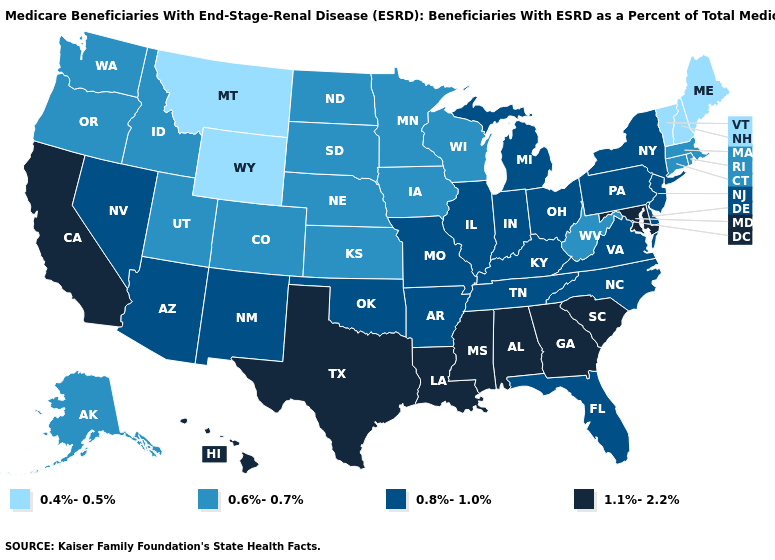What is the value of Mississippi?
Short answer required. 1.1%-2.2%. Name the states that have a value in the range 0.6%-0.7%?
Concise answer only. Alaska, Colorado, Connecticut, Idaho, Iowa, Kansas, Massachusetts, Minnesota, Nebraska, North Dakota, Oregon, Rhode Island, South Dakota, Utah, Washington, West Virginia, Wisconsin. Name the states that have a value in the range 0.4%-0.5%?
Be succinct. Maine, Montana, New Hampshire, Vermont, Wyoming. Name the states that have a value in the range 0.6%-0.7%?
Give a very brief answer. Alaska, Colorado, Connecticut, Idaho, Iowa, Kansas, Massachusetts, Minnesota, Nebraska, North Dakota, Oregon, Rhode Island, South Dakota, Utah, Washington, West Virginia, Wisconsin. What is the value of Delaware?
Short answer required. 0.8%-1.0%. Does the first symbol in the legend represent the smallest category?
Quick response, please. Yes. Does Indiana have a lower value than Louisiana?
Answer briefly. Yes. What is the lowest value in states that border Maine?
Concise answer only. 0.4%-0.5%. What is the highest value in the West ?
Keep it brief. 1.1%-2.2%. Does the map have missing data?
Short answer required. No. Name the states that have a value in the range 0.6%-0.7%?
Short answer required. Alaska, Colorado, Connecticut, Idaho, Iowa, Kansas, Massachusetts, Minnesota, Nebraska, North Dakota, Oregon, Rhode Island, South Dakota, Utah, Washington, West Virginia, Wisconsin. Does Illinois have the lowest value in the MidWest?
Keep it brief. No. What is the value of Oklahoma?
Write a very short answer. 0.8%-1.0%. Name the states that have a value in the range 0.8%-1.0%?
Answer briefly. Arizona, Arkansas, Delaware, Florida, Illinois, Indiana, Kentucky, Michigan, Missouri, Nevada, New Jersey, New Mexico, New York, North Carolina, Ohio, Oklahoma, Pennsylvania, Tennessee, Virginia. Does the first symbol in the legend represent the smallest category?
Be succinct. Yes. 